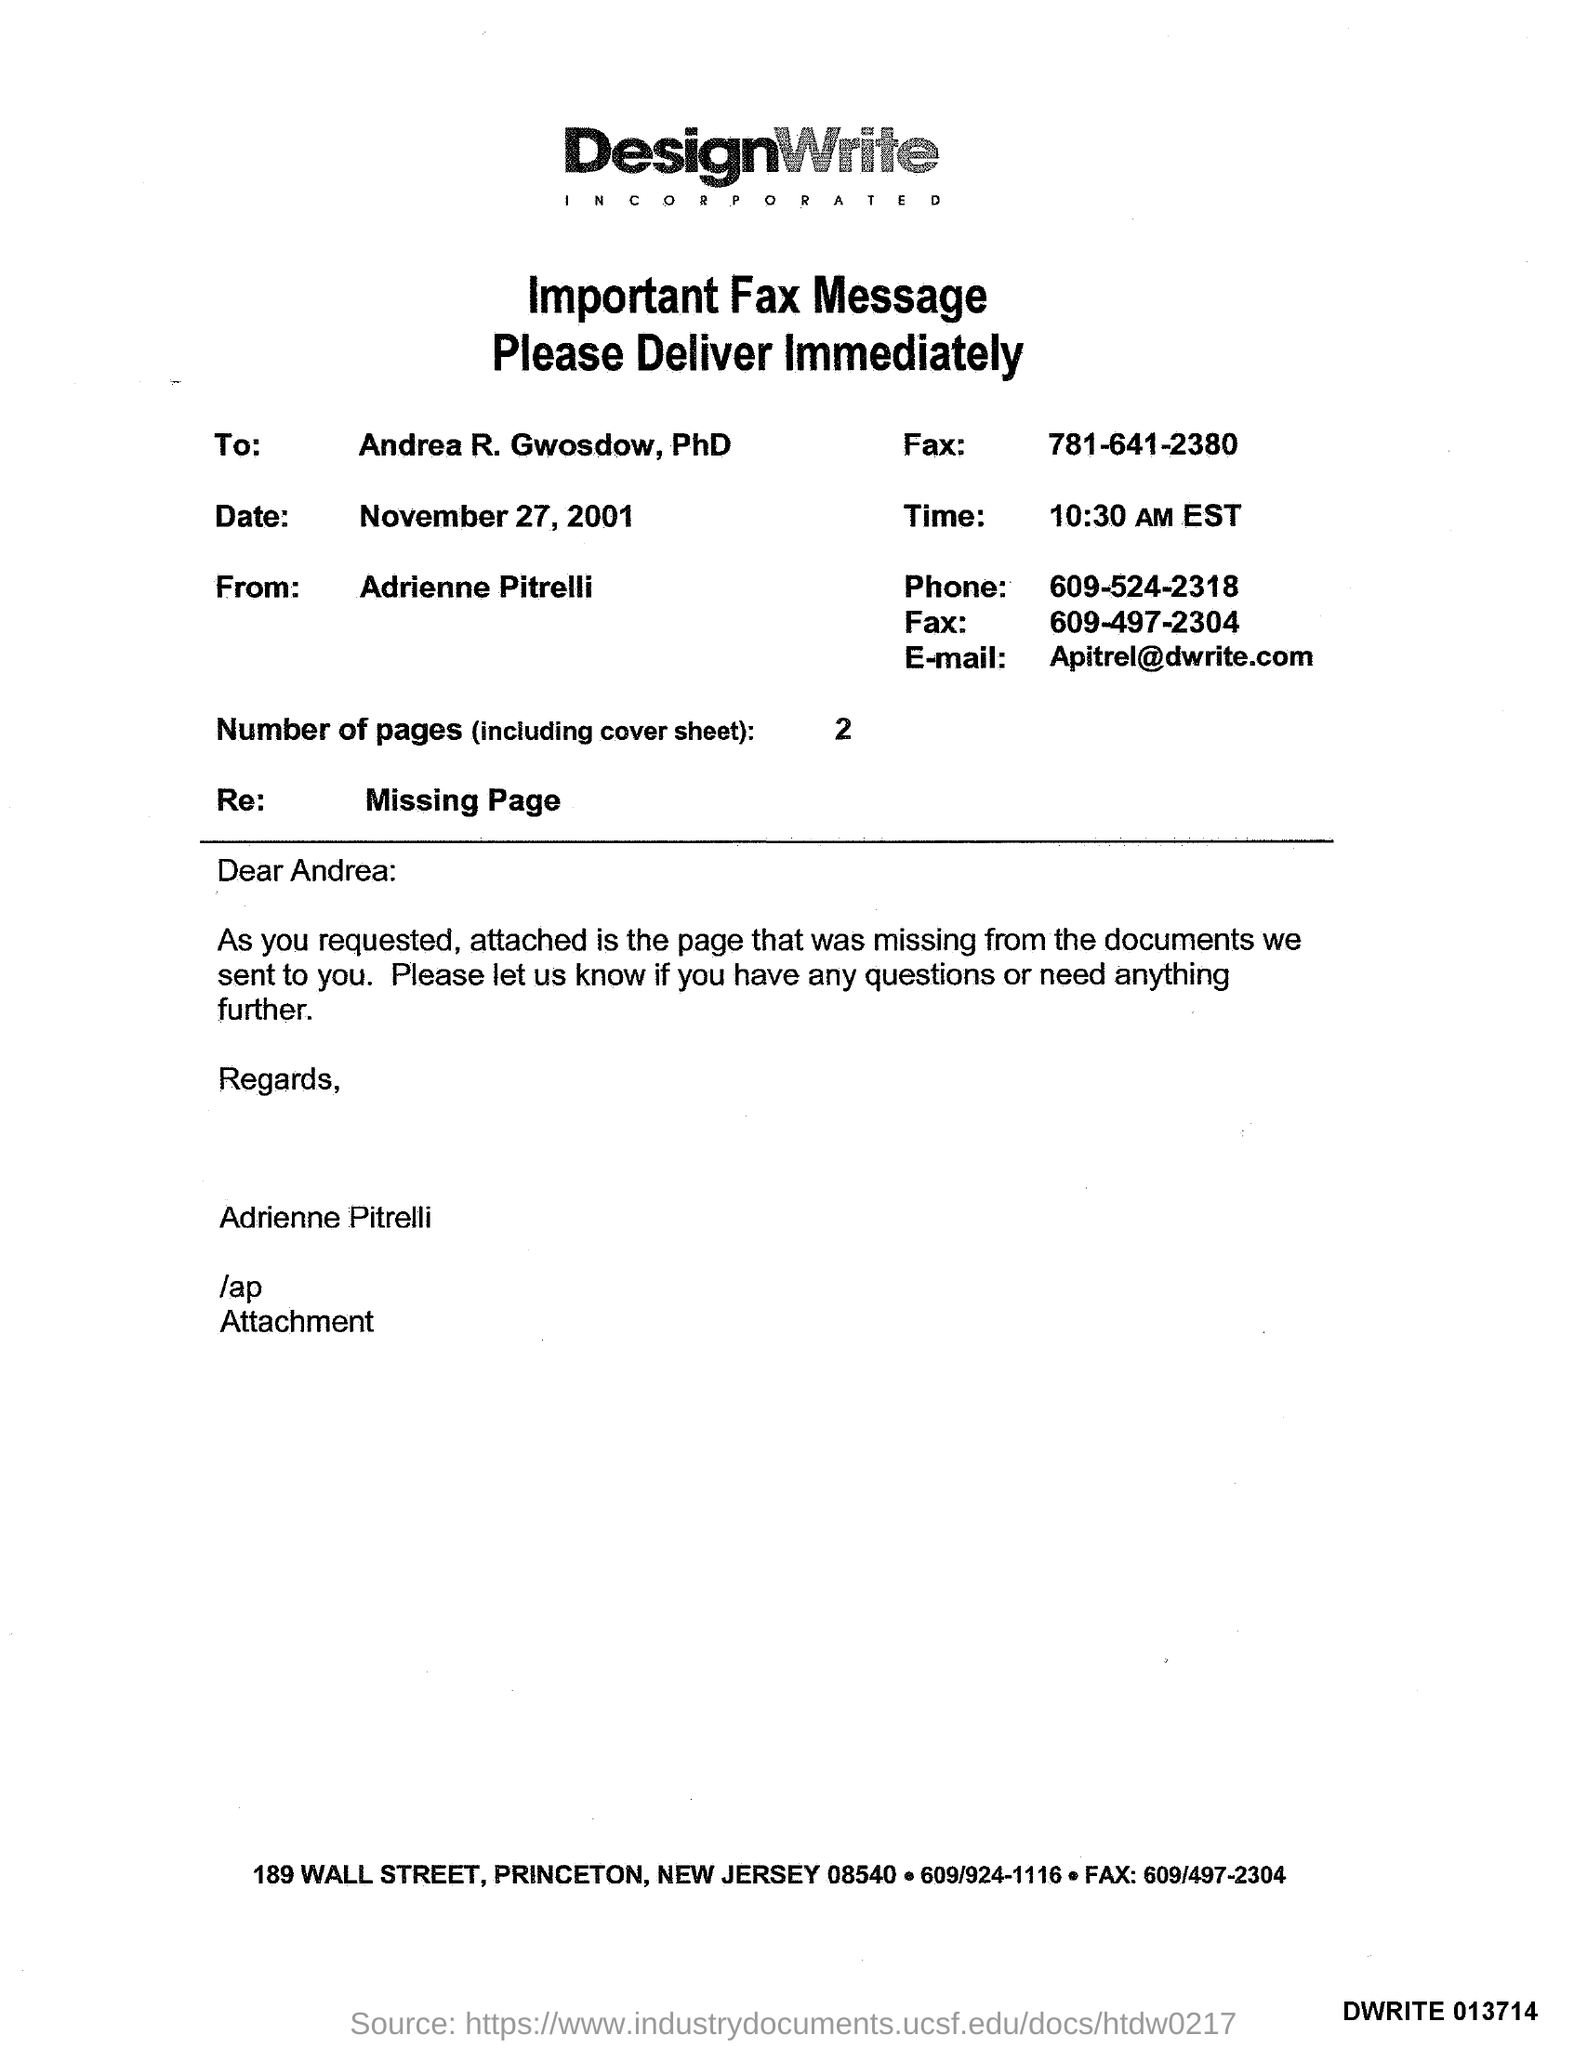What is the Title of the document ?
Ensure brevity in your answer.  DesignWrite INCORPORATED. Who is the Memorandum addressed to ?
Your answer should be compact. Andrea R. Gwosdow. What is the date mentioned in the document ?
Make the answer very short. November 27, 2001. What is the Receiver Fax Number ?
Your answer should be compact. 781-641-2380. What is the Sender E-mail Address ?
Your answer should be very brief. Apitrel@dwrite.com. Who is the Memorandum from ?
Your response must be concise. Adrienne Pitrelli. What is the Sender Fax Number ?
Your answer should be compact. 609-497-2304. How many Pages are there in this sheet ?
Keep it short and to the point. 2. What is the Sender Phone Number ?
Give a very brief answer. 609-524-2318. What is written in the "Re" field ?
Make the answer very short. Missing Page. 